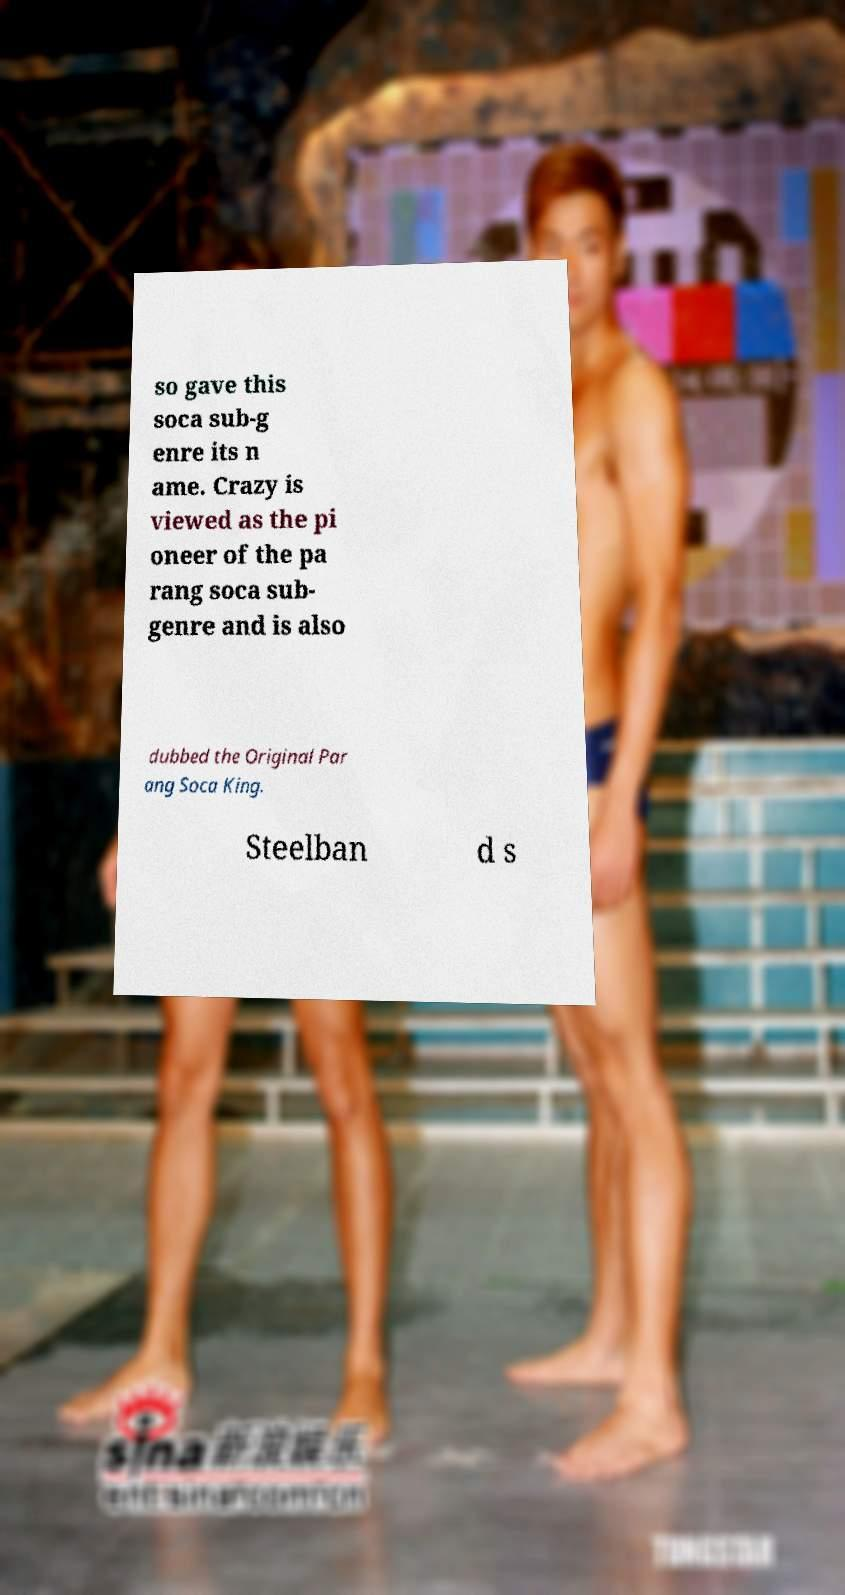Could you assist in decoding the text presented in this image and type it out clearly? so gave this soca sub-g enre its n ame. Crazy is viewed as the pi oneer of the pa rang soca sub- genre and is also dubbed the Original Par ang Soca King. Steelban d s 